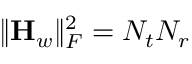<formula> <loc_0><loc_0><loc_500><loc_500>\| { H _ { w } } \| _ { F } ^ { 2 } = N _ { t } N _ { r }</formula> 